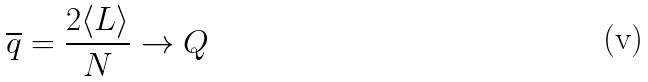Convert formula to latex. <formula><loc_0><loc_0><loc_500><loc_500>\overline { q } = \frac { 2 \langle L \rangle } { N } \rightarrow Q</formula> 